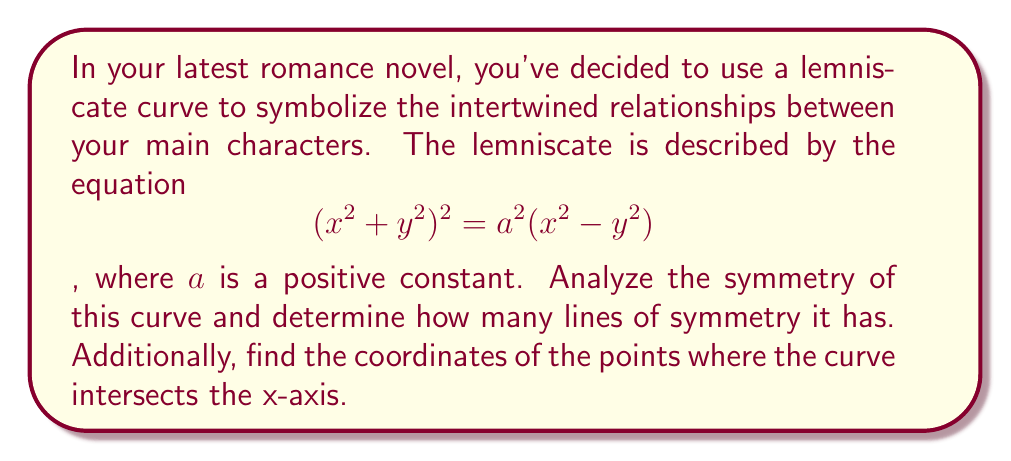Can you answer this question? To analyze the symmetry of the lemniscate curve, let's follow these steps:

1) First, let's consider the equation of the lemniscate:
   $$(x^2 + y^2)^2 = a^2(x^2 - y^2)$$

2) To check for symmetry about the x-axis, replace y with -y:
   $$(x^2 + (-y)^2)^2 = a^2(x^2 - (-y)^2)$$
   $$(x^2 + y^2)^2 = a^2(x^2 - y^2)$$
   This is the same as the original equation, so the curve is symmetric about the x-axis.

3) To check for symmetry about the y-axis, replace x with -x:
   $$((-x)^2 + y^2)^2 = a^2((-x)^2 - y^2)$$
   $$(x^2 + y^2)^2 = a^2(x^2 - y^2)$$
   This is also the same as the original equation, so the curve is symmetric about the y-axis.

4) To check for symmetry about the lines y = x and y = -x, we can replace x with y and y with x:
   $$(y^2 + x^2)^2 = a^2(y^2 - x^2)$$
   This is not the same as the original equation, so the curve is not symmetric about y = x or y = -x.

5) To find the points where the curve intersects the x-axis, set y = 0 in the original equation:
   $$(x^2 + 0^2)^2 = a^2(x^2 - 0^2)$$
   $$x^4 = a^2x^2$$
   $$x^2(x^2 - a^2) = 0$$
   
   Solving this equation:
   $$x = 0$$ or $$x^2 = a^2$$
   $$x = 0$$ or $$x = \pm a$$

Therefore, the lemniscate has two lines of symmetry: the x-axis and the y-axis.
The curve intersects the x-axis at three points: $(0, 0)$, $(a, 0)$, and $(-a, 0)$.
Answer: The lemniscate curve has 2 lines of symmetry. It intersects the x-axis at the points $(0, 0)$, $(a, 0)$, and $(-a, 0)$. 